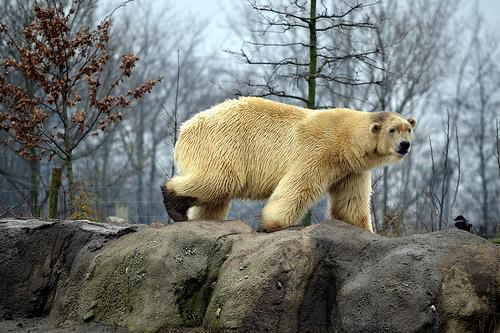How many bears are there?
Give a very brief answer. 1. 